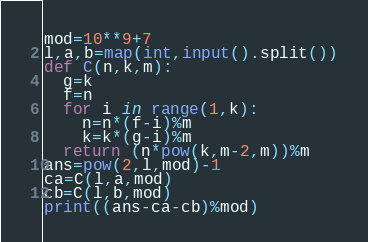Convert code to text. <code><loc_0><loc_0><loc_500><loc_500><_Python_>mod=10**9+7
l,a,b=map(int,input().split())
def C(n,k,m):
  g=k
  f=n
  for i in range(1,k):
    n=n*(f-i)%m
    k=k*(g-i)%m
  return (n*pow(k,m-2,m))%m
ans=pow(2,l,mod)-1
ca=C(l,a,mod)
cb=C(l,b,mod)
print((ans-ca-cb)%mod)</code> 